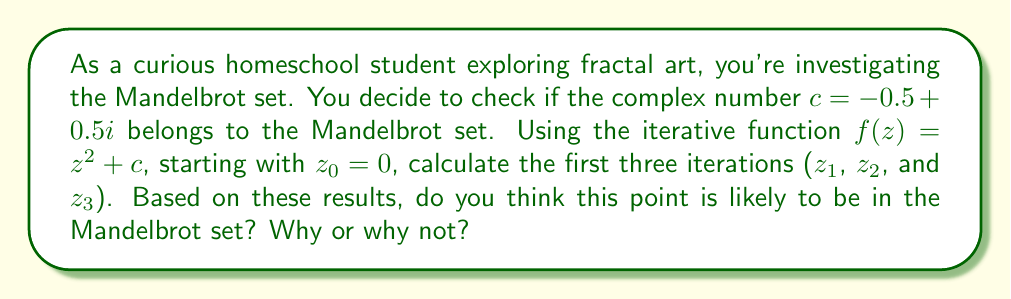Can you solve this math problem? Let's approach this step-by-step:

1) The iterative function for the Mandelbrot set is $f(z) = z^2 + c$, where $c$ is the complex number we're investigating.

2) We start with $z_0 = 0$ and $c = -0.5 + 0.5i$

3) Let's calculate the first three iterations:

   For $z_1$:
   $$z_1 = (0)^2 + (-0.5 + 0.5i) = -0.5 + 0.5i$$

   For $z_2$:
   $$\begin{align*}
   z_2 &= (-0.5 + 0.5i)^2 + (-0.5 + 0.5i) \\
   &= (0.25 - 0.5i + 0.25i^2) + (-0.5 + 0.5i) \\
   &= (0.25 - 0.5i - 0.25) + (-0.5 + 0.5i) \\
   &= -0.5
   \end{align*}$$

   For $z_3$:
   $$\begin{align*}
   z_3 &= (-0.5)^2 + (-0.5 + 0.5i) \\
   &= 0.25 + (-0.5 + 0.5i) \\
   &= -0.25 + 0.5i
   \end{align*}$$

4) To determine if a point is in the Mandelbrot set, we check if the absolute value of $z_n$ stays bounded as $n$ approaches infinity. In practice, if $|z_n| > 2$ for any $n$, we can conclude that the point is not in the set.

5) Let's calculate the absolute values:
   $|z_1| = \sqrt{(-0.5)^2 + (0.5)^2} = \sqrt{0.5} \approx 0.707$
   $|z_2| = |-0.5| = 0.5$
   $|z_3| = \sqrt{(-0.25)^2 + (0.5)^2} = \sqrt{0.3125} \approx 0.559$

6) We can see that all these values are less than 2 and seem to be staying bounded.

Based on these first three iterations, it appears that this point might be in the Mandelbrot set. The absolute values are not growing larger than 2, and in fact, they seem to be oscillating within a bounded range. However, to be certain, we would need to continue the iterations further or use more advanced techniques to prove it definitively.
Answer: Based on the first three iterations, the point $c = -0.5 + 0.5i$ is likely to be in the Mandelbrot set. The absolute values of $z_1$, $z_2$, and $z_3$ are all less than 2 and do not show a clear trend of increasing, suggesting that the sequence may remain bounded as $n$ approaches infinity. 